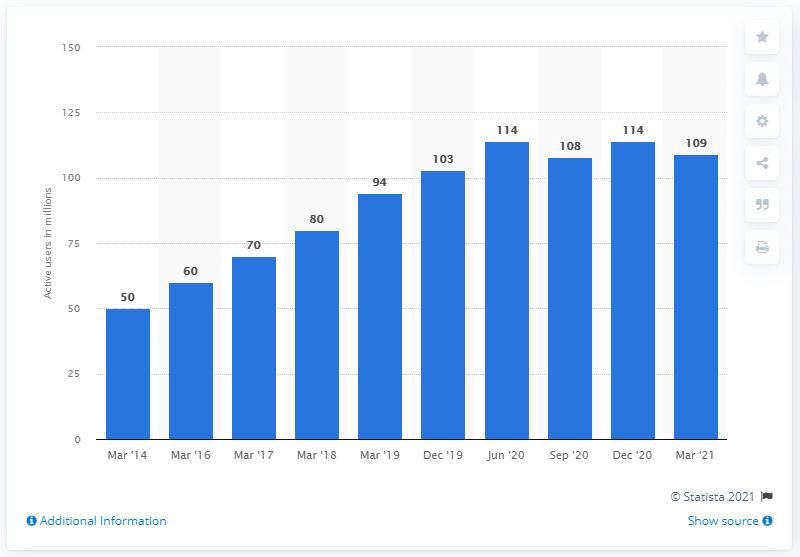Identify some key points in this picture. In March 2014, there were 50 monthly active users. As of March 2021, the PlayStation Network had 109 monthly active users. 